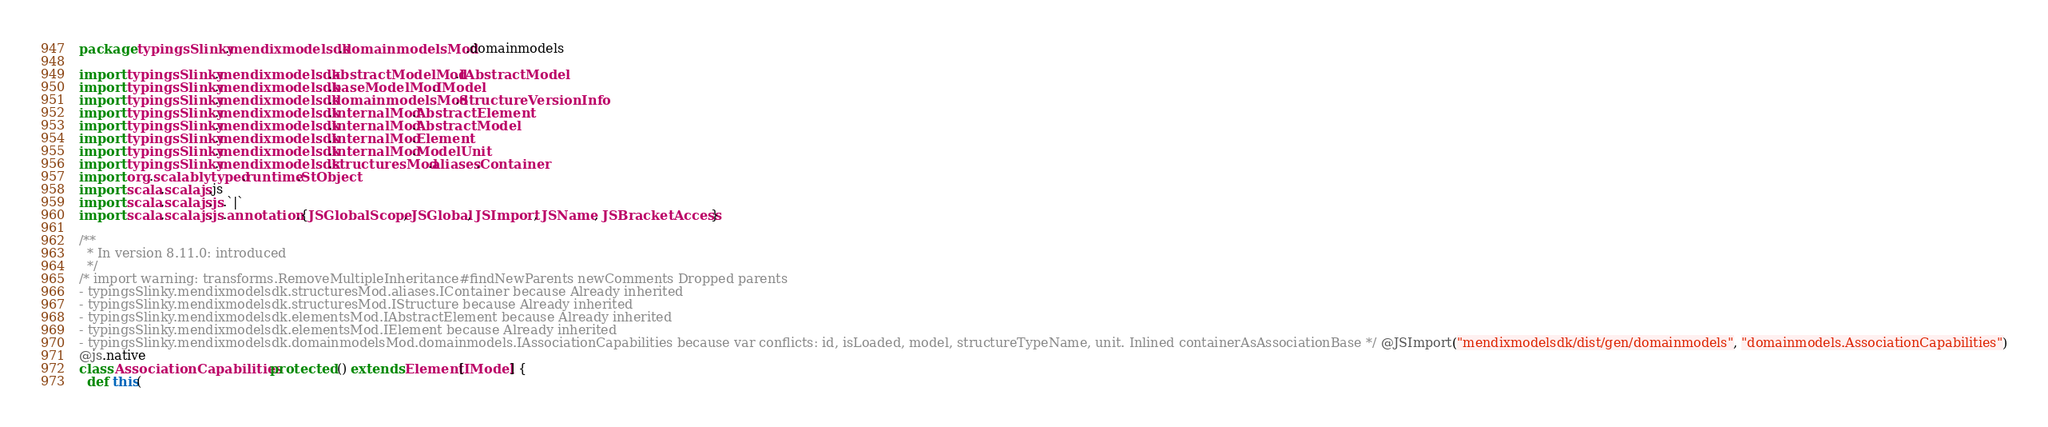Convert code to text. <code><loc_0><loc_0><loc_500><loc_500><_Scala_>package typingsSlinky.mendixmodelsdk.domainmodelsMod.domainmodels

import typingsSlinky.mendixmodelsdk.abstractModelMod.IAbstractModel
import typingsSlinky.mendixmodelsdk.baseModelMod.IModel
import typingsSlinky.mendixmodelsdk.domainmodelsMod.StructureVersionInfo
import typingsSlinky.mendixmodelsdk.internalMod.AbstractElement
import typingsSlinky.mendixmodelsdk.internalMod.AbstractModel
import typingsSlinky.mendixmodelsdk.internalMod.Element
import typingsSlinky.mendixmodelsdk.internalMod.ModelUnit
import typingsSlinky.mendixmodelsdk.structuresMod.aliases.Container
import org.scalablytyped.runtime.StObject
import scala.scalajs.js
import scala.scalajs.js.`|`
import scala.scalajs.js.annotation.{JSGlobalScope, JSGlobal, JSImport, JSName, JSBracketAccess}

/**
  * In version 8.11.0: introduced
  */
/* import warning: transforms.RemoveMultipleInheritance#findNewParents newComments Dropped parents 
- typingsSlinky.mendixmodelsdk.structuresMod.aliases.IContainer because Already inherited
- typingsSlinky.mendixmodelsdk.structuresMod.IStructure because Already inherited
- typingsSlinky.mendixmodelsdk.elementsMod.IAbstractElement because Already inherited
- typingsSlinky.mendixmodelsdk.elementsMod.IElement because Already inherited
- typingsSlinky.mendixmodelsdk.domainmodelsMod.domainmodels.IAssociationCapabilities because var conflicts: id, isLoaded, model, structureTypeName, unit. Inlined containerAsAssociationBase */ @JSImport("mendixmodelsdk/dist/gen/domainmodels", "domainmodels.AssociationCapabilities")
@js.native
class AssociationCapabilities protected () extends Element[IModel] {
  def this(</code> 